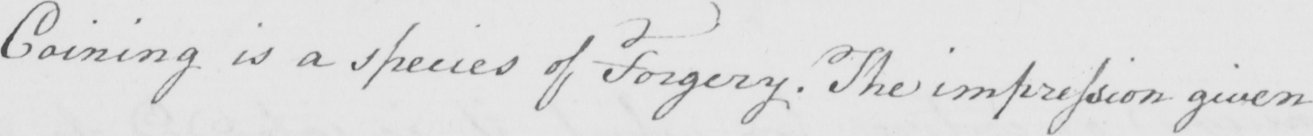Please provide the text content of this handwritten line. Coining is a species of Forgery . The impression given 